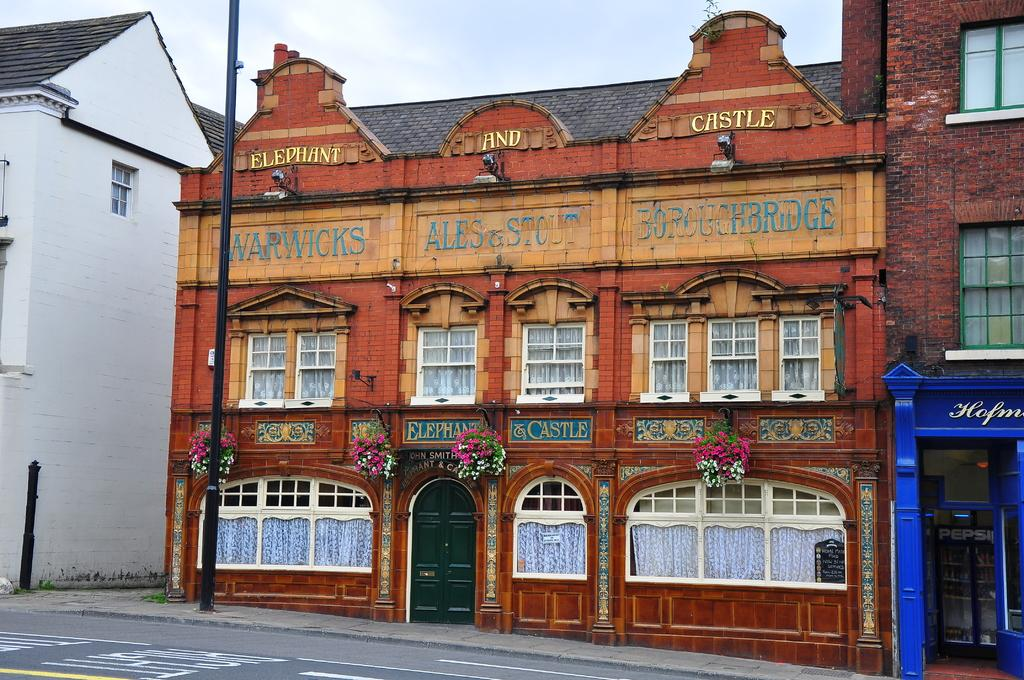What is the color of the building on the right side of the image? The building on the right side of the image is brown-colored. What colors are the flowers in the image? The flowers in the image are pink and white. What is the color of the building on the left side of the image? The building on the left side of the image is white-colored. What color is the sky in the background of the image? The sky in the background of the image is white. Are there any amusement park rides visible in the image? There are no amusement park rides present in the image. What type of grass is growing in front of the white building? There is no grass visible in the image; it only features buildings and flowers. 